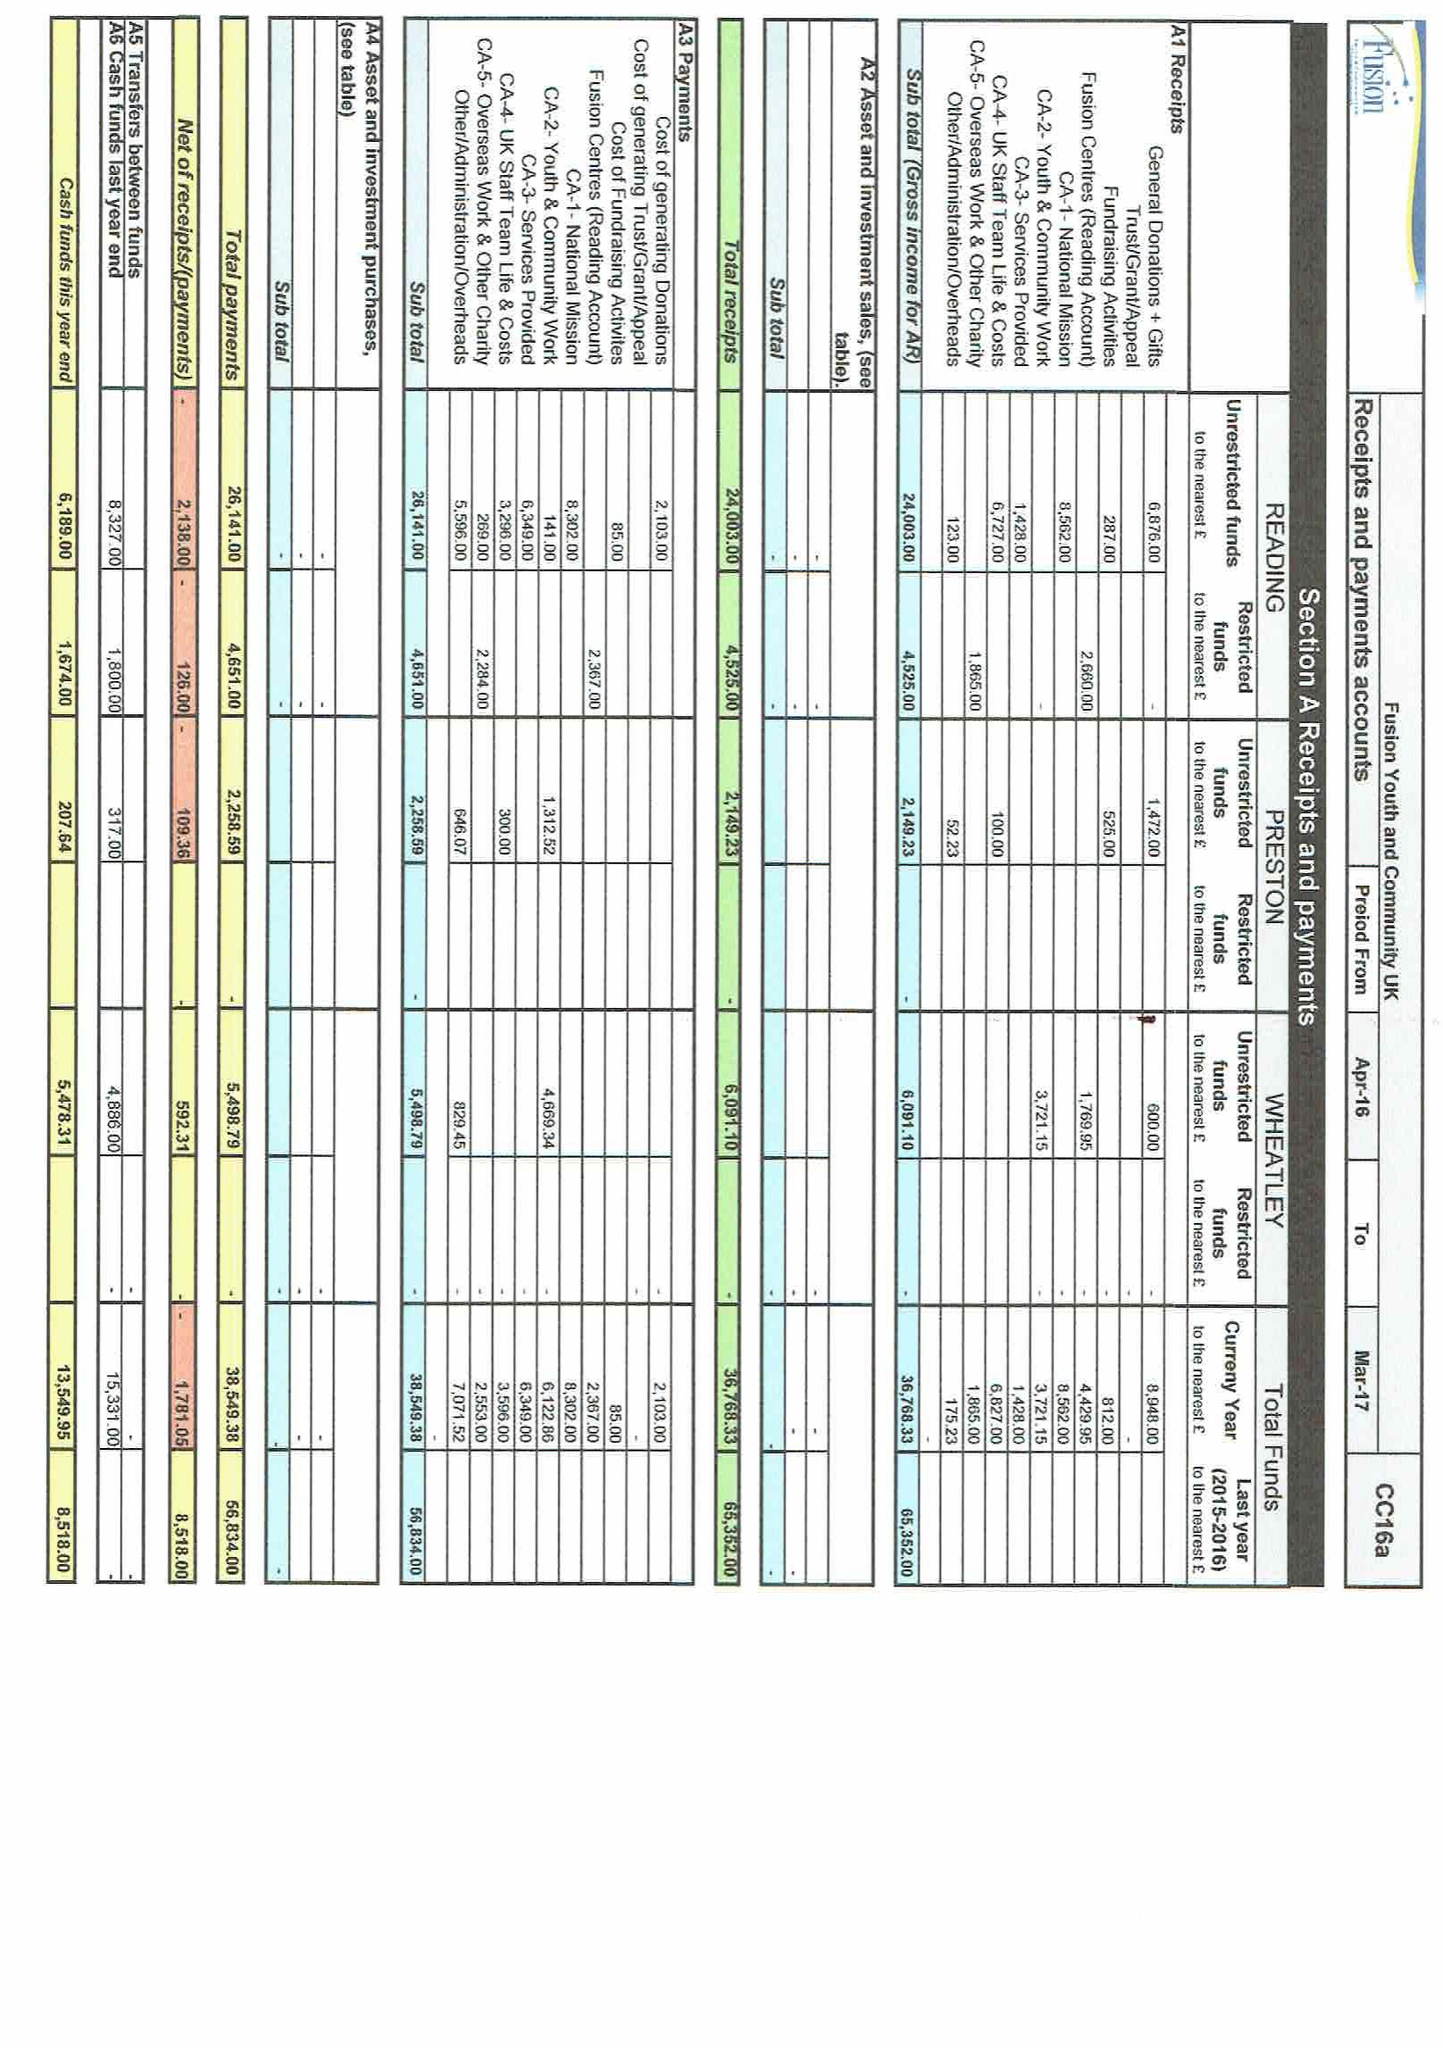What is the value for the charity_number?
Answer the question using a single word or phrase. 1112078 